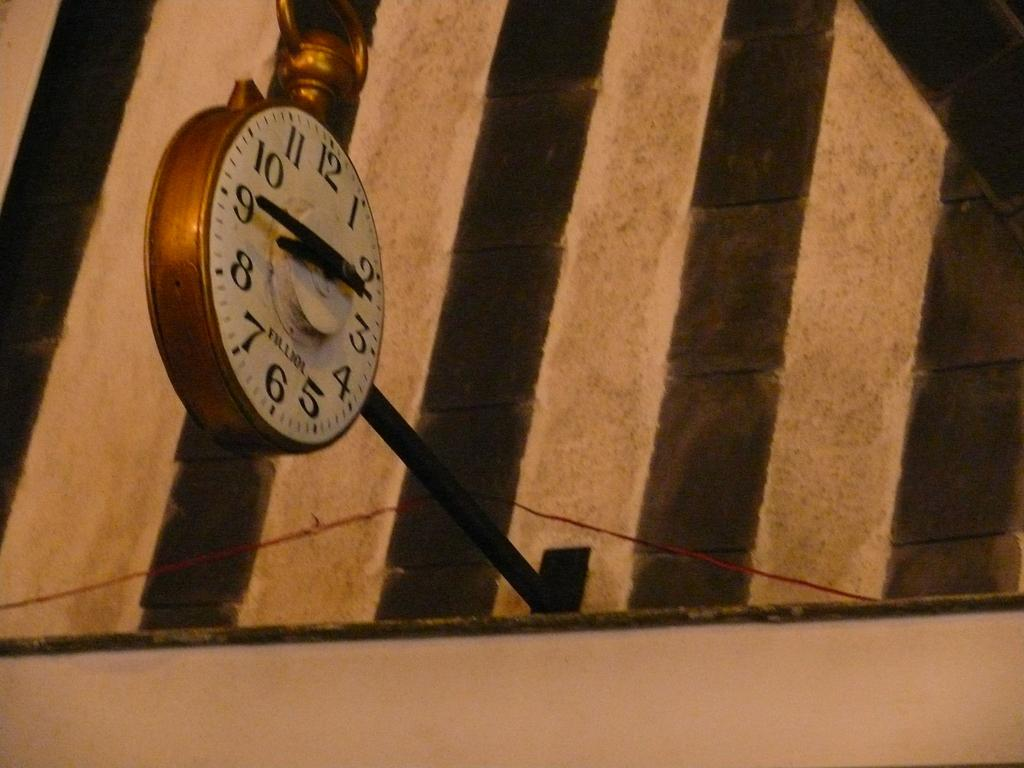<image>
Present a compact description of the photo's key features. A large golden clock says that it's 8:45. 